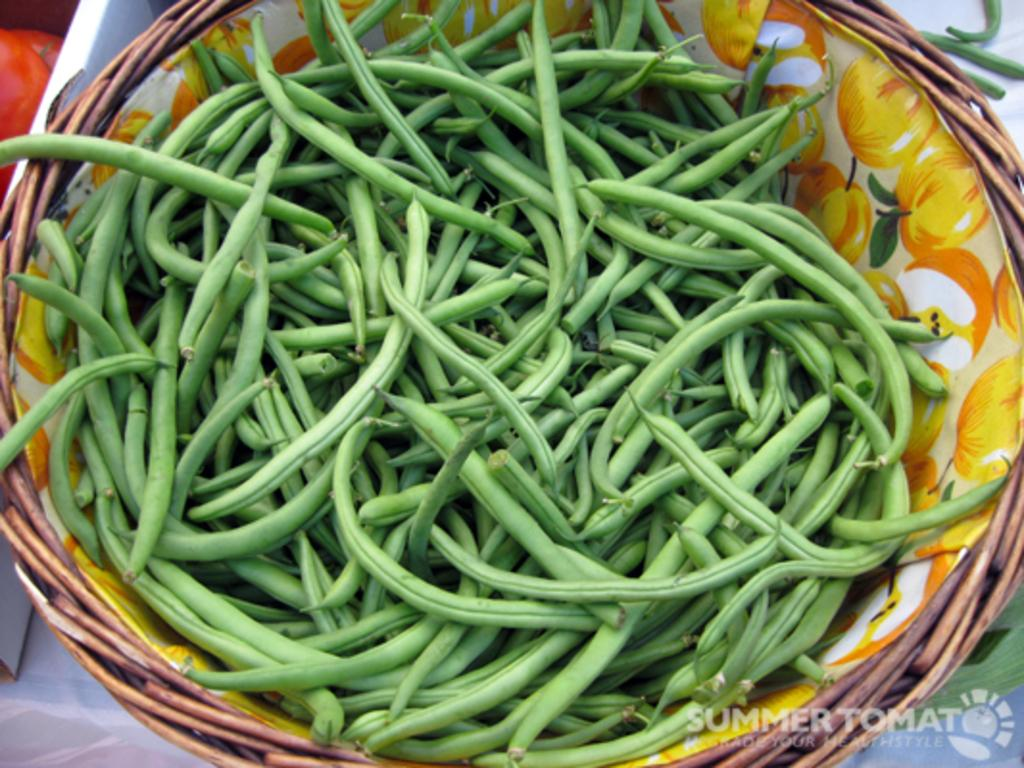What is in the basket that is visible in the picture? There are beans in the basket. What is the main object in the picture? There is a basket in the picture. Can you describe the object on the left side of the picture? Unfortunately, the provided facts do not give any information about the object on the left side of the picture. What type of sofa can be seen in the picture? There is no sofa present in the picture; it only features a basket with beans. What advice does the coach give to the players in the picture? There is no coach or players present in the picture; it only features a basket with beans. 